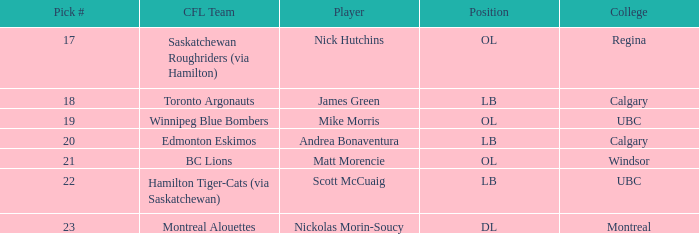What position is the player who went to Regina?  OL. 